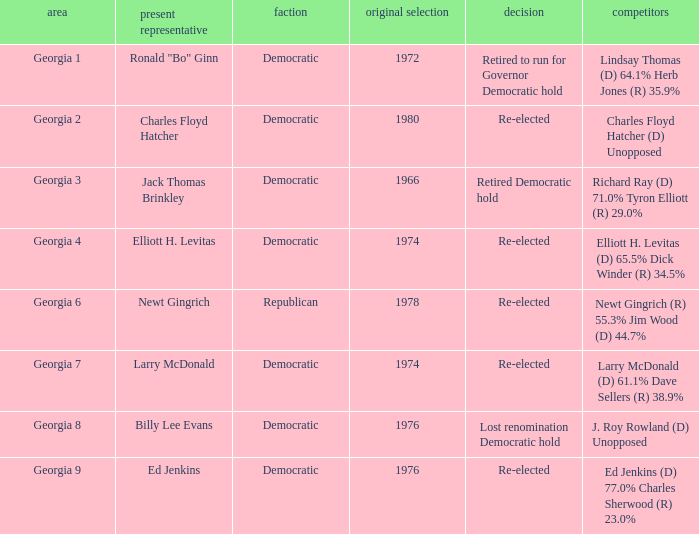Name the districk for larry mcdonald Georgia 7. 